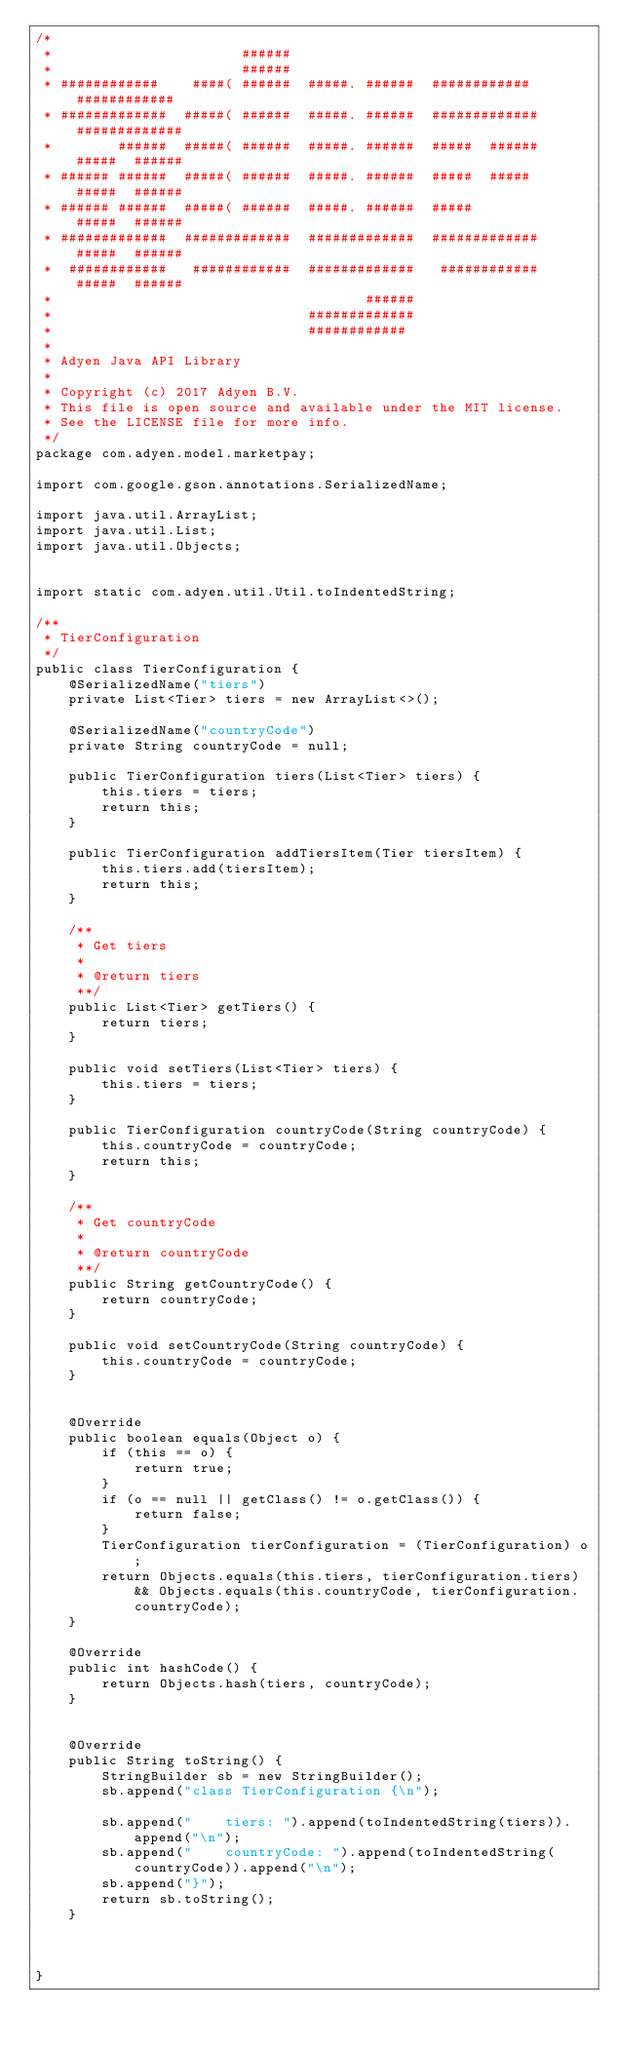Convert code to text. <code><loc_0><loc_0><loc_500><loc_500><_Java_>/*
 *                       ######
 *                       ######
 * ############    ####( ######  #####. ######  ############   ############
 * #############  #####( ######  #####. ######  #############  #############
 *        ######  #####( ######  #####. ######  #####  ######  #####  ######
 * ###### ######  #####( ######  #####. ######  #####  #####   #####  ######
 * ###### ######  #####( ######  #####. ######  #####          #####  ######
 * #############  #############  #############  #############  #####  ######
 *  ############   ############  #############   ############  #####  ######
 *                                      ######
 *                               #############
 *                               ############
 *
 * Adyen Java API Library
 *
 * Copyright (c) 2017 Adyen B.V.
 * This file is open source and available under the MIT license.
 * See the LICENSE file for more info.
 */
package com.adyen.model.marketpay;

import com.google.gson.annotations.SerializedName;

import java.util.ArrayList;
import java.util.List;
import java.util.Objects;


import static com.adyen.util.Util.toIndentedString;

/**
 * TierConfiguration
 */
public class TierConfiguration {
    @SerializedName("tiers")
    private List<Tier> tiers = new ArrayList<>();

    @SerializedName("countryCode")
    private String countryCode = null;

    public TierConfiguration tiers(List<Tier> tiers) {
        this.tiers = tiers;
        return this;
    }

    public TierConfiguration addTiersItem(Tier tiersItem) {
        this.tiers.add(tiersItem);
        return this;
    }

    /**
     * Get tiers
     *
     * @return tiers
     **/
    public List<Tier> getTiers() {
        return tiers;
    }

    public void setTiers(List<Tier> tiers) {
        this.tiers = tiers;
    }

    public TierConfiguration countryCode(String countryCode) {
        this.countryCode = countryCode;
        return this;
    }

    /**
     * Get countryCode
     *
     * @return countryCode
     **/
    public String getCountryCode() {
        return countryCode;
    }

    public void setCountryCode(String countryCode) {
        this.countryCode = countryCode;
    }


    @Override
    public boolean equals(Object o) {
        if (this == o) {
            return true;
        }
        if (o == null || getClass() != o.getClass()) {
            return false;
        }
        TierConfiguration tierConfiguration = (TierConfiguration) o;
        return Objects.equals(this.tiers, tierConfiguration.tiers) && Objects.equals(this.countryCode, tierConfiguration.countryCode);
    }

    @Override
    public int hashCode() {
        return Objects.hash(tiers, countryCode);
    }


    @Override
    public String toString() {
        StringBuilder sb = new StringBuilder();
        sb.append("class TierConfiguration {\n");

        sb.append("    tiers: ").append(toIndentedString(tiers)).append("\n");
        sb.append("    countryCode: ").append(toIndentedString(countryCode)).append("\n");
        sb.append("}");
        return sb.toString();
    }



}

</code> 